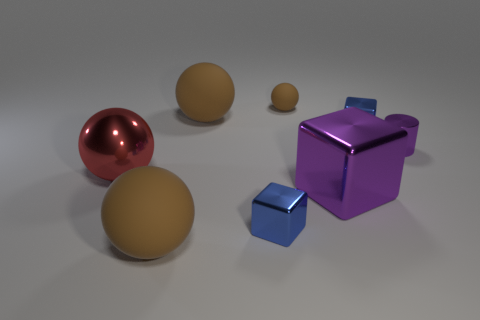Does the cylinder have the same color as the large block?
Offer a very short reply. Yes. How many things are blue shiny blocks that are to the left of the large purple metal cube or large red things?
Your answer should be compact. 2. There is a rubber sphere that is in front of the big metallic sphere in front of the tiny purple metal cylinder; what number of large metal things are on the left side of it?
Make the answer very short. 1. The small blue metallic object left of the tiny blue object that is right of the blue thing in front of the large purple object is what shape?
Keep it short and to the point. Cube. What number of other objects are there of the same color as the small cylinder?
Your answer should be compact. 1. What shape is the large metal thing that is right of the large brown matte sphere behind the large red thing?
Keep it short and to the point. Cube. How many big purple things are behind the purple shiny cylinder?
Make the answer very short. 0. Are there any tiny blue things made of the same material as the red object?
Make the answer very short. Yes. There is a cube that is the same size as the red ball; what material is it?
Your answer should be compact. Metal. There is a ball that is right of the metallic sphere and in front of the purple metal cylinder; how big is it?
Your answer should be compact. Large. 